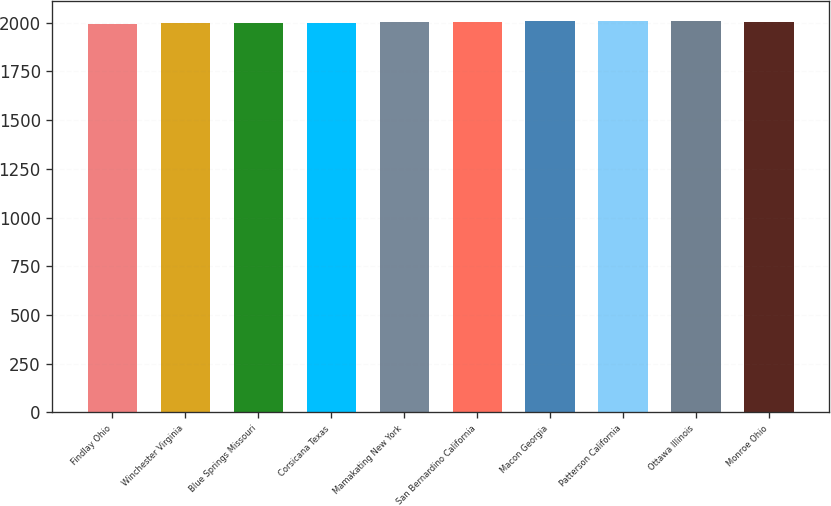Convert chart. <chart><loc_0><loc_0><loc_500><loc_500><bar_chart><fcel>Findlay Ohio<fcel>Winchester Virginia<fcel>Blue Springs Missouri<fcel>Corsicana Texas<fcel>Mamakating New York<fcel>San Bernardino California<fcel>Macon Georgia<fcel>Patterson California<fcel>Ottawa Illinois<fcel>Monroe Ohio<nl><fcel>1994<fcel>1997<fcel>1999<fcel>2001<fcel>2004.6<fcel>2006.4<fcel>2008.2<fcel>2010<fcel>2011.8<fcel>2002.8<nl></chart> 